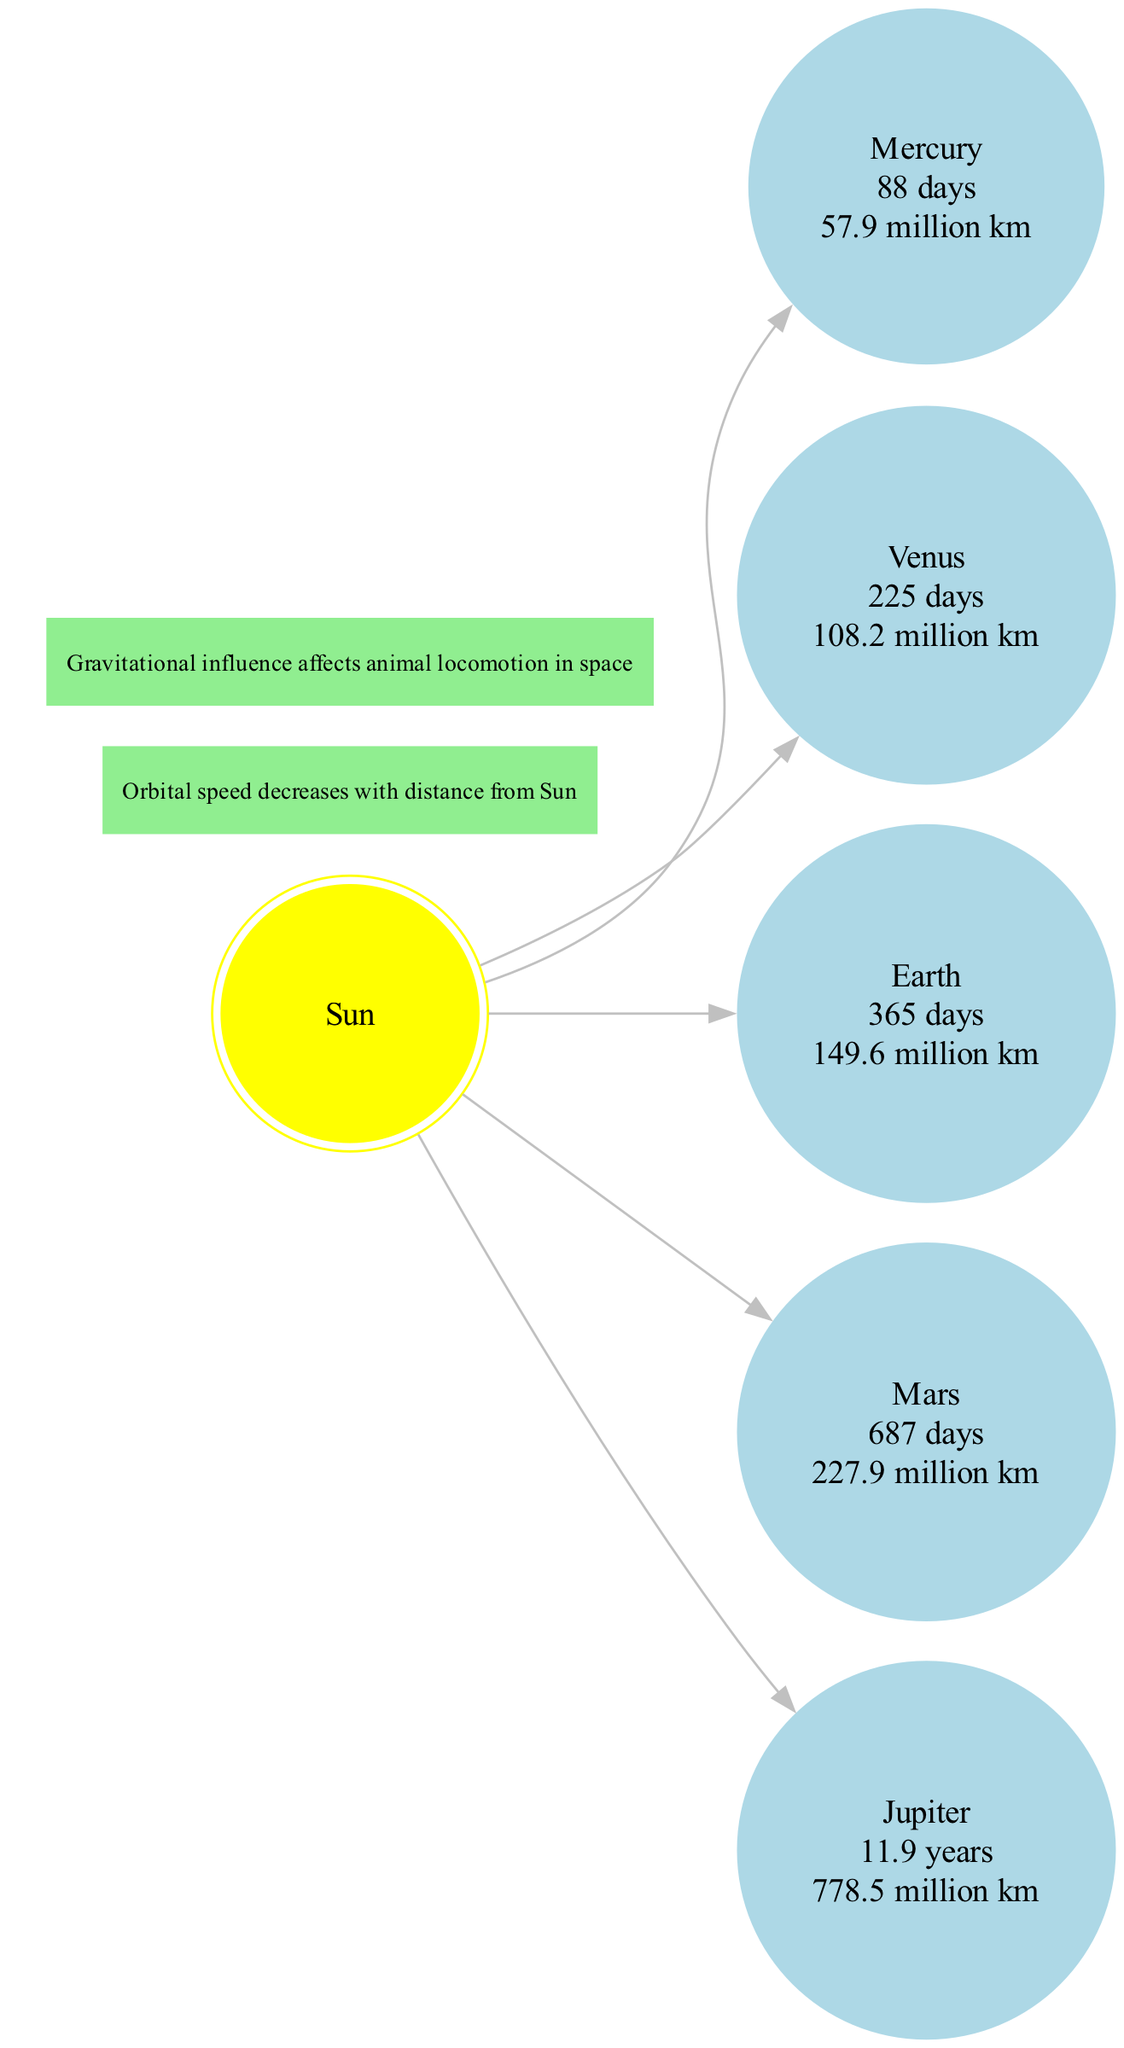What is the orbital period of Mars? The diagram shows the planet Mars and provides detailed information in its node, which includes the orbital period listed as 687 days.
Answer: 687 days Which planet has the longest orbital period? By examining the orbital periods of all planets in the diagram, we find that Jupiter's orbital period is listed as 11.9 years, which is the longest among the planets shown.
Answer: 11.9 years What is the average distance of Venus from the Sun? In the diagram, Venus's node provides the average distance, which is noted as 108.2 million km.
Answer: 108.2 million km How many planets are shown in the diagram? The planets listed in the diagram include Mercury, Venus, Earth, Mars, and Jupiter, which amounts to a total of five planets.
Answer: 5 Which planet has an average distance of 57.9 million km? Looking at the nodes for distance, only Mercury's node provides this exact value, indicating that Mercury is the planet with an average distance of 57.9 million km.
Answer: Mercury What is the relationship between orbital distance and speed? The diagram notes that orbital speed decreases with distance from the Sun, meaning that planets further away from the Sun will have slower orbital speeds.
Answer: Decreases Which planet is closest to the Sun? From the nodes, it is clear that Mercury is the closest planet to the Sun, as it is the first planet listed in terms of distance.
Answer: Mercury How many nodes represent planets in the diagram? The diagram clearly shows five nodes representing the different planets, which can be counted directly.
Answer: 5 What is a significant note regarding gravitational influence? The diagram includes a note stating that gravitational influence affects animal locomotion in space, highlighting the relationship between celestial mechanics and biology.
Answer: Affects animal locomotion in space 